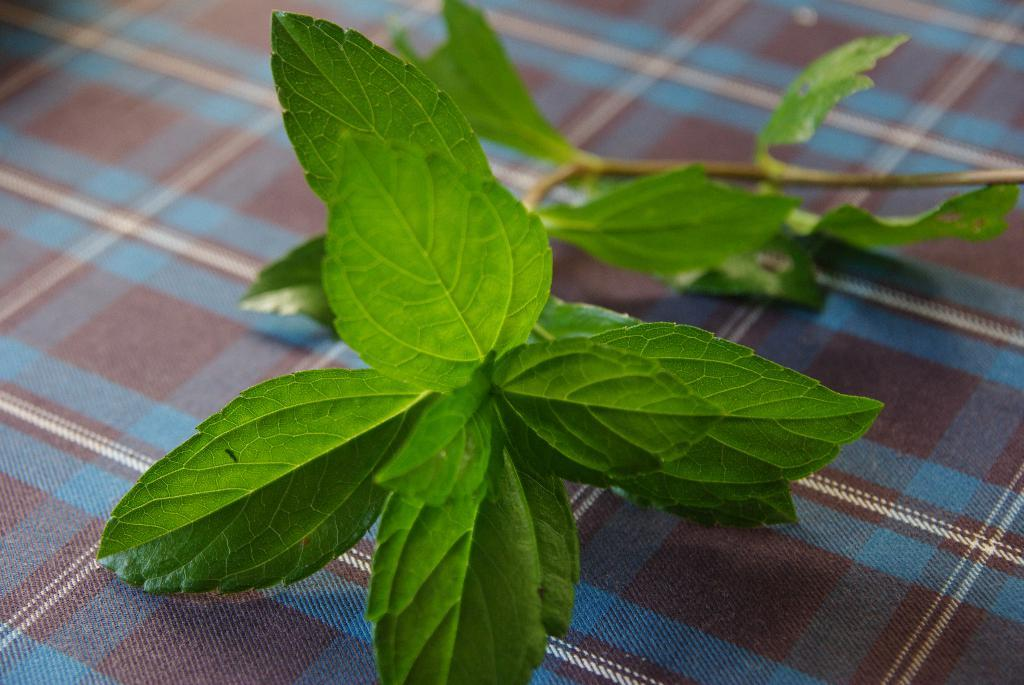What type of vegetation can be seen in the image? There are leaves in the image. Where are the leaves located? The leaves are placed on a table. Can you describe the position of the table in the image? The table is in the center of the image. What type of clover is visible on the table in the image? There is no clover present in the image; it features leaves on a table. What type of lace is used to decorate the table in the image? There is no lace present in the image; it only shows leaves on a table. 